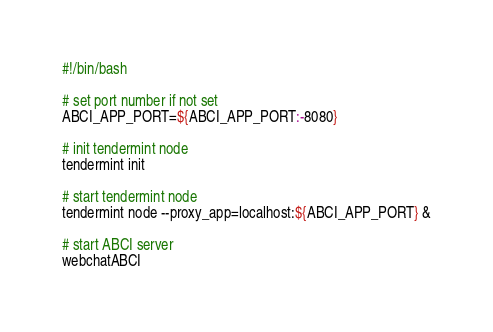<code> <loc_0><loc_0><loc_500><loc_500><_Bash_>#!/bin/bash

# set port number if not set
ABCI_APP_PORT=${ABCI_APP_PORT:-8080}

# init tendermint node
tendermint init

# start tendermint node
tendermint node --proxy_app=localhost:${ABCI_APP_PORT} &

# start ABCI server
webchatABCI
</code> 